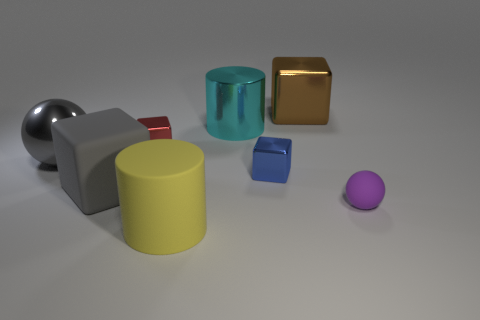Subtract all shiny blocks. How many blocks are left? 1 Subtract 2 blocks. How many blocks are left? 2 Add 1 large gray balls. How many objects exist? 9 Subtract all green blocks. Subtract all gray balls. How many blocks are left? 4 Subtract all cylinders. How many objects are left? 6 Subtract 1 purple spheres. How many objects are left? 7 Subtract all yellow cylinders. Subtract all large gray rubber things. How many objects are left? 6 Add 4 rubber things. How many rubber things are left? 7 Add 6 small red objects. How many small red objects exist? 7 